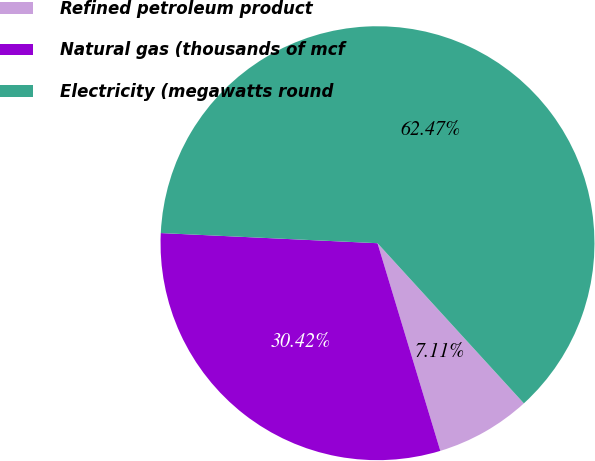Convert chart to OTSL. <chart><loc_0><loc_0><loc_500><loc_500><pie_chart><fcel>Refined petroleum product<fcel>Natural gas (thousands of mcf<fcel>Electricity (megawatts round<nl><fcel>7.11%<fcel>30.42%<fcel>62.47%<nl></chart> 